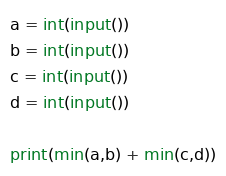<code> <loc_0><loc_0><loc_500><loc_500><_Python_>a = int(input())
b = int(input())
c = int(input())
d = int(input())

print(min(a,b) + min(c,d))</code> 